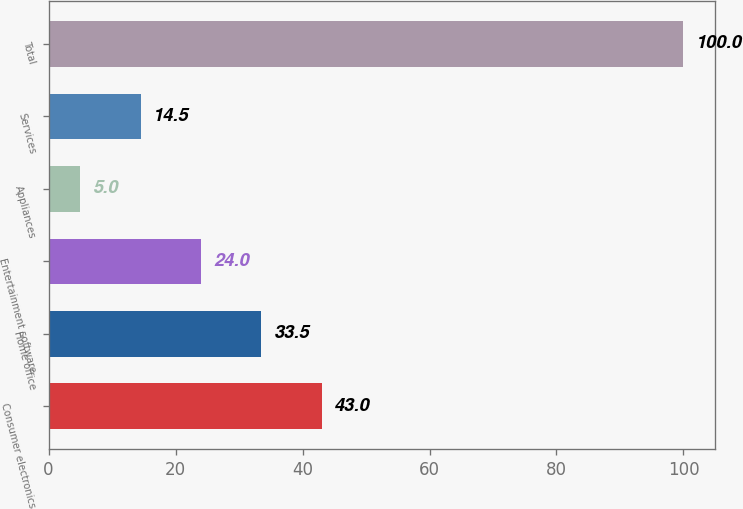Convert chart to OTSL. <chart><loc_0><loc_0><loc_500><loc_500><bar_chart><fcel>Consumer electronics<fcel>Home office<fcel>Entertainment software<fcel>Appliances<fcel>Services<fcel>Total<nl><fcel>43<fcel>33.5<fcel>24<fcel>5<fcel>14.5<fcel>100<nl></chart> 